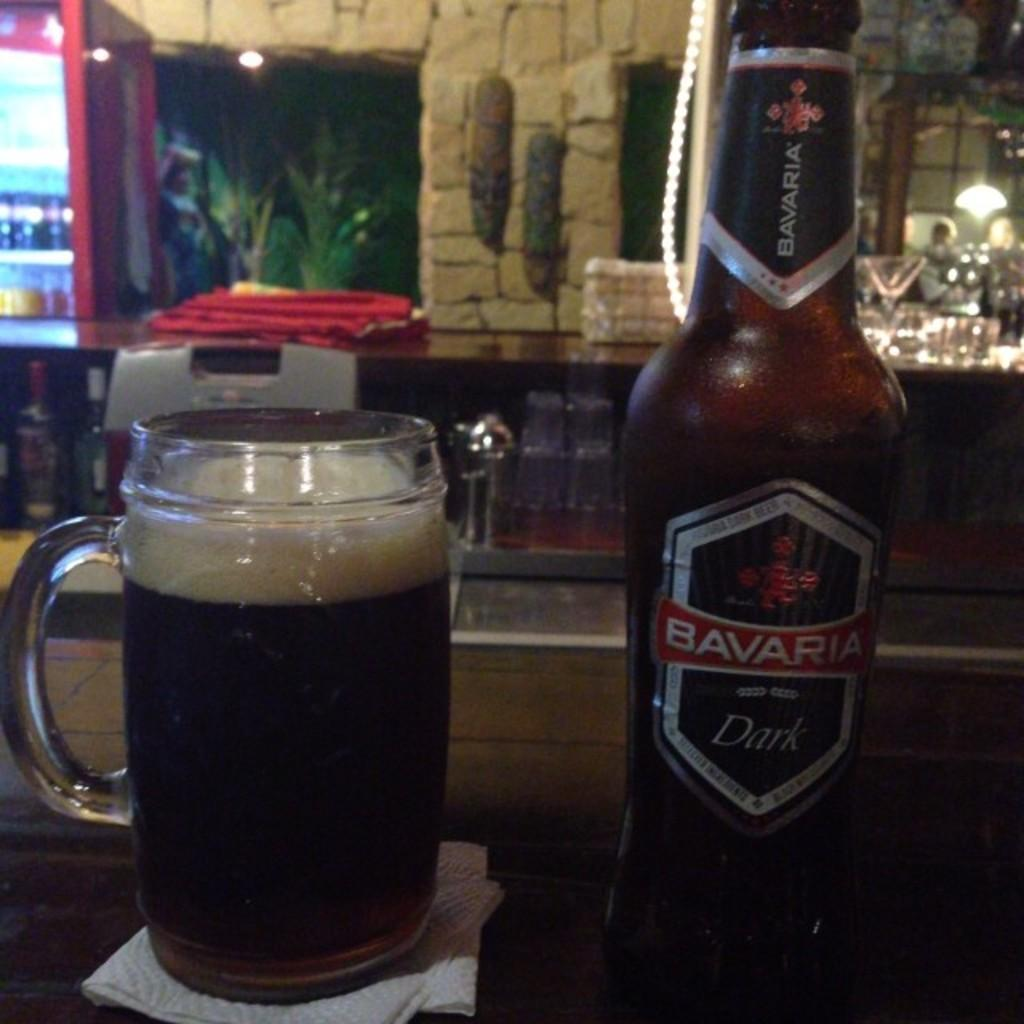<image>
Describe the image concisely. A bottle of Bavaria branded dark beer is sitting next to a full glass pint. 